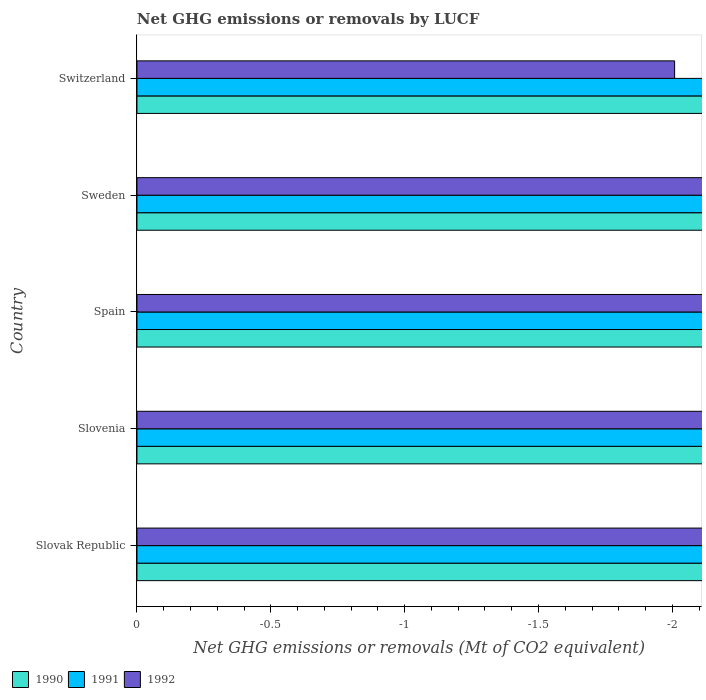Are the number of bars per tick equal to the number of legend labels?
Give a very brief answer. No. Are the number of bars on each tick of the Y-axis equal?
Provide a succinct answer. Yes. How many bars are there on the 4th tick from the top?
Offer a very short reply. 0. What is the net GHG emissions or removals by LUCF in 1990 in Spain?
Offer a very short reply. 0. What is the average net GHG emissions or removals by LUCF in 1990 per country?
Give a very brief answer. 0. In how many countries, is the net GHG emissions or removals by LUCF in 1992 greater than -1 Mt?
Make the answer very short. 0. In how many countries, is the net GHG emissions or removals by LUCF in 1991 greater than the average net GHG emissions or removals by LUCF in 1991 taken over all countries?
Ensure brevity in your answer.  0. Is it the case that in every country, the sum of the net GHG emissions or removals by LUCF in 1991 and net GHG emissions or removals by LUCF in 1990 is greater than the net GHG emissions or removals by LUCF in 1992?
Offer a very short reply. No. How many countries are there in the graph?
Your response must be concise. 5. What is the difference between two consecutive major ticks on the X-axis?
Make the answer very short. 0.5. Are the values on the major ticks of X-axis written in scientific E-notation?
Give a very brief answer. No. Does the graph contain grids?
Provide a short and direct response. No. How many legend labels are there?
Provide a succinct answer. 3. How are the legend labels stacked?
Your answer should be compact. Horizontal. What is the title of the graph?
Your response must be concise. Net GHG emissions or removals by LUCF. Does "2008" appear as one of the legend labels in the graph?
Keep it short and to the point. No. What is the label or title of the X-axis?
Your answer should be compact. Net GHG emissions or removals (Mt of CO2 equivalent). What is the Net GHG emissions or removals (Mt of CO2 equivalent) of 1991 in Slovak Republic?
Keep it short and to the point. 0. What is the Net GHG emissions or removals (Mt of CO2 equivalent) of 1990 in Slovenia?
Offer a very short reply. 0. What is the Net GHG emissions or removals (Mt of CO2 equivalent) in 1990 in Spain?
Your answer should be very brief. 0. What is the Net GHG emissions or removals (Mt of CO2 equivalent) of 1991 in Switzerland?
Ensure brevity in your answer.  0. What is the total Net GHG emissions or removals (Mt of CO2 equivalent) of 1990 in the graph?
Ensure brevity in your answer.  0. What is the total Net GHG emissions or removals (Mt of CO2 equivalent) in 1991 in the graph?
Offer a terse response. 0. What is the total Net GHG emissions or removals (Mt of CO2 equivalent) in 1992 in the graph?
Your answer should be very brief. 0. What is the average Net GHG emissions or removals (Mt of CO2 equivalent) of 1990 per country?
Keep it short and to the point. 0. What is the average Net GHG emissions or removals (Mt of CO2 equivalent) in 1991 per country?
Your answer should be very brief. 0. 